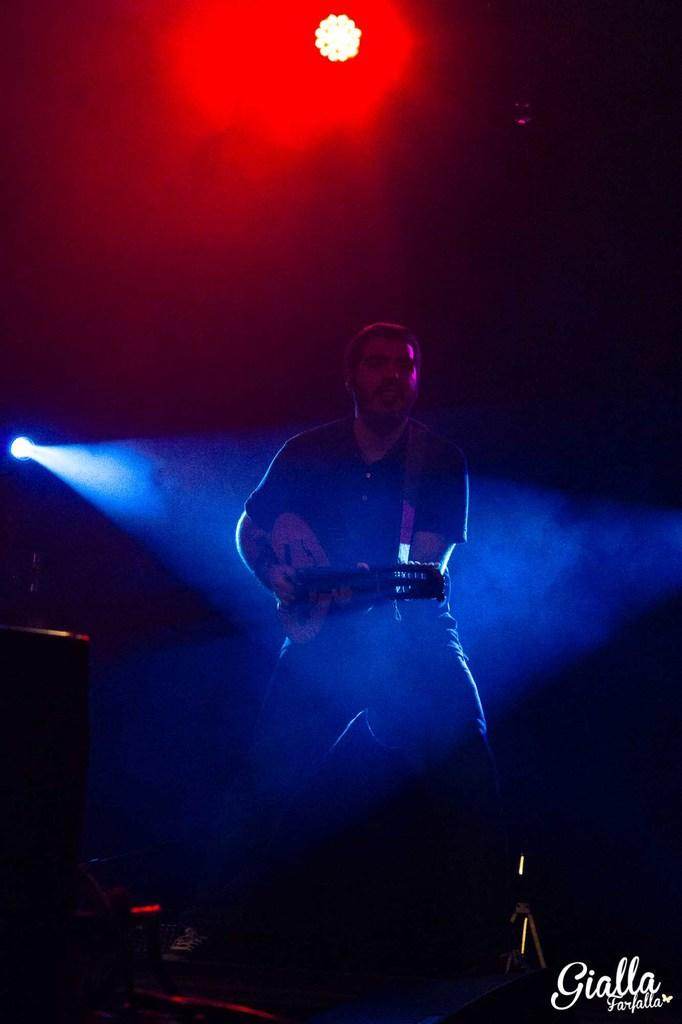Who is present in the image? There is a man in the image. What is the man holding in the image? The man is holding a guitar. What can be seen in the image besides the man and the guitar? There are lights in the image. Can you describe the overall lighting in the image? The image appears to be slightly dark. What type of whip is the man using to play the guitar in the image? There is no whip present in the image, and the man is not using any whip to play the guitar. 